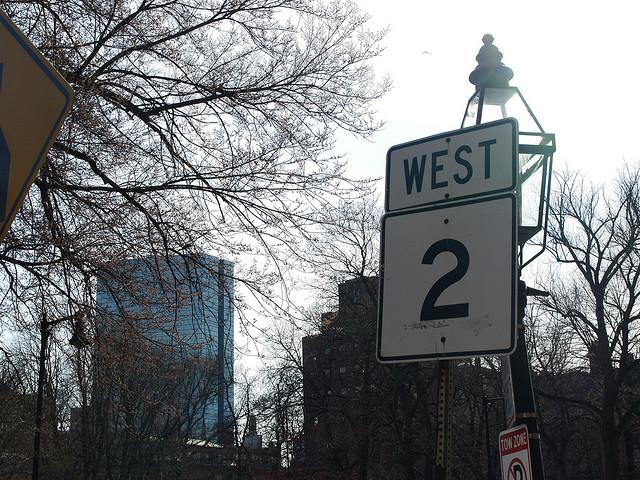What route number is this?
Concise answer only. 2. Is parking allowed in this area?
Concise answer only. No. What letter does that word end with?
Concise answer only. T. 